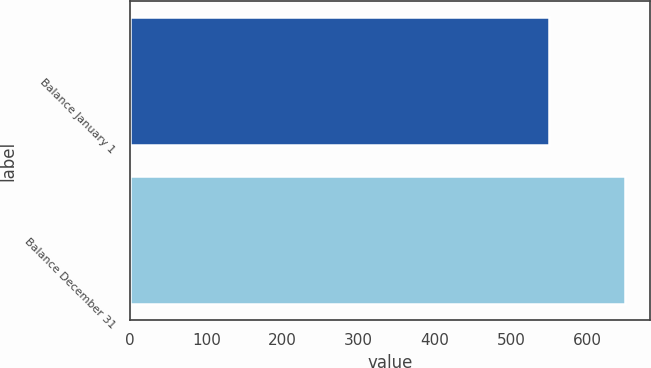<chart> <loc_0><loc_0><loc_500><loc_500><bar_chart><fcel>Balance January 1<fcel>Balance December 31<nl><fcel>550<fcel>650<nl></chart> 